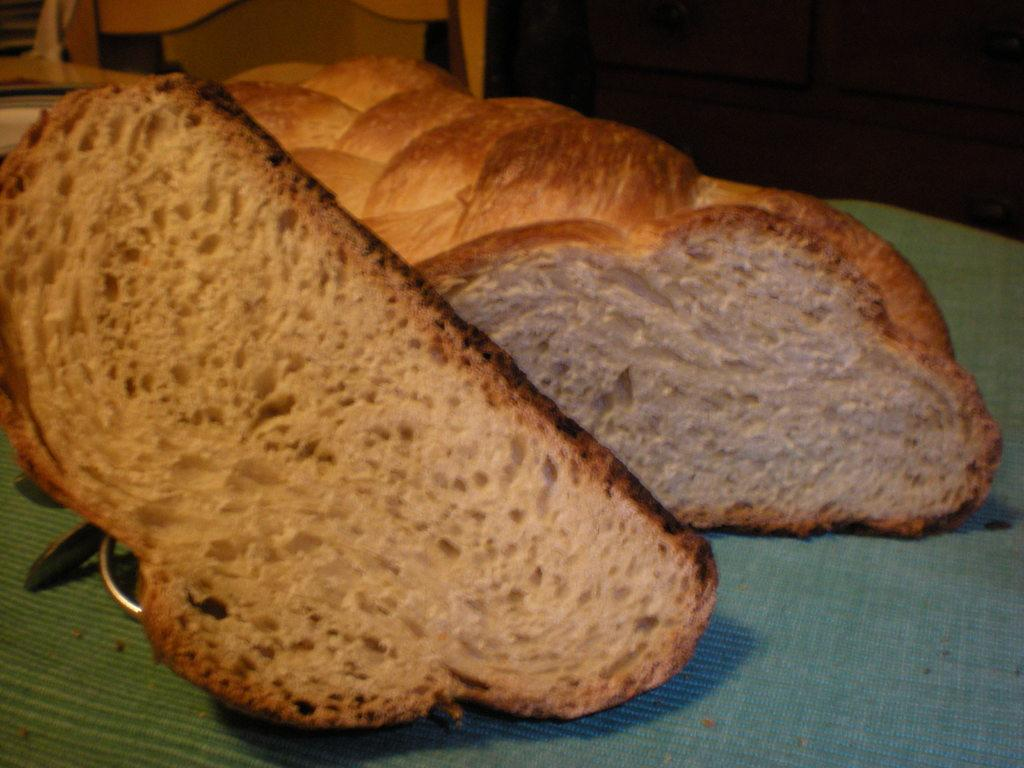What type of food is shown in the image? There are two brown bread slices in the image. What is the bread placed on? The bread slices are placed on a green cloth. What type of mint is growing on the bread slices in the image? There is no mint growing on the bread slices in the image; it only shows two brown bread slices placed on a green cloth. 